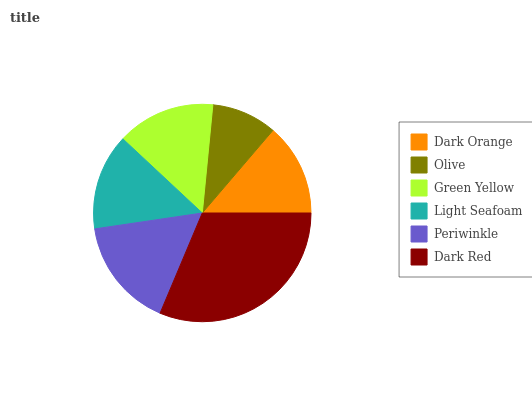Is Olive the minimum?
Answer yes or no. Yes. Is Dark Red the maximum?
Answer yes or no. Yes. Is Green Yellow the minimum?
Answer yes or no. No. Is Green Yellow the maximum?
Answer yes or no. No. Is Green Yellow greater than Olive?
Answer yes or no. Yes. Is Olive less than Green Yellow?
Answer yes or no. Yes. Is Olive greater than Green Yellow?
Answer yes or no. No. Is Green Yellow less than Olive?
Answer yes or no. No. Is Green Yellow the high median?
Answer yes or no. Yes. Is Light Seafoam the low median?
Answer yes or no. Yes. Is Light Seafoam the high median?
Answer yes or no. No. Is Dark Red the low median?
Answer yes or no. No. 